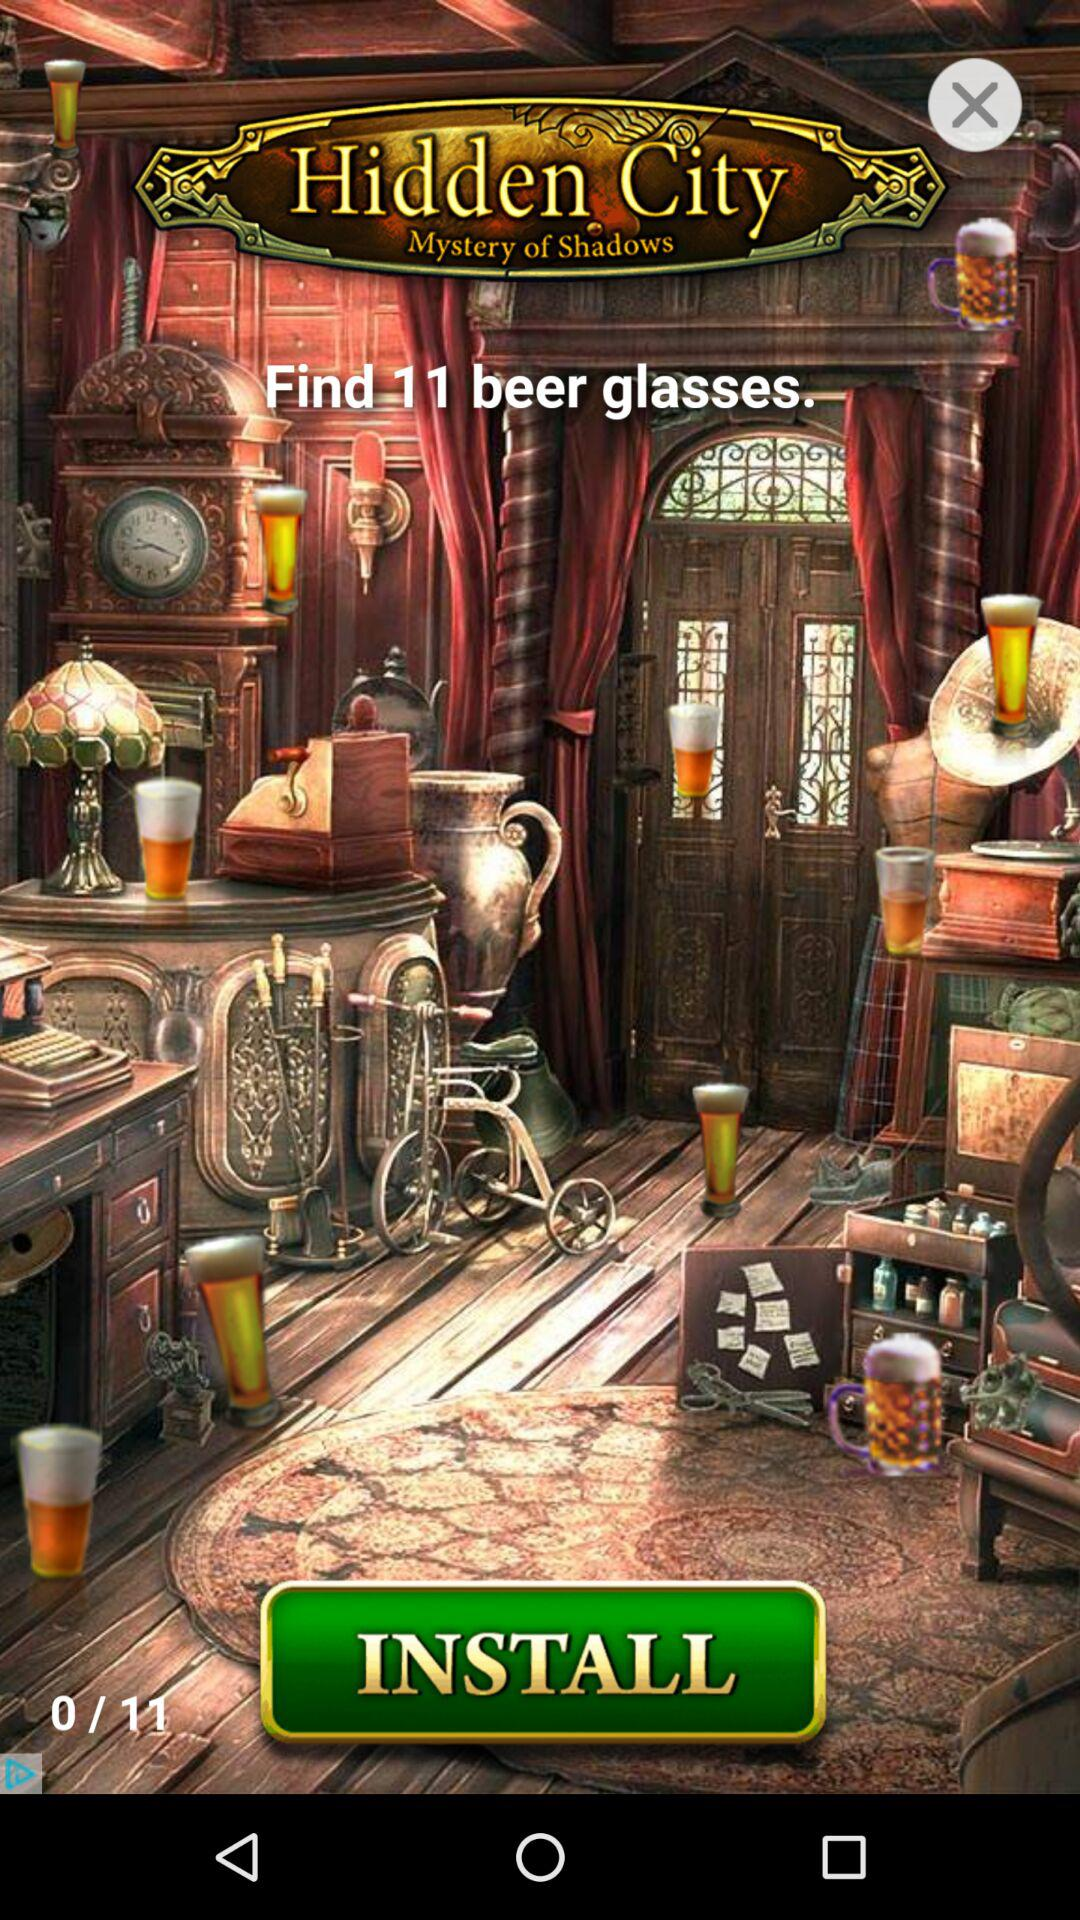How many beer glasses have I found so far?
Answer the question using a single word or phrase. 0 